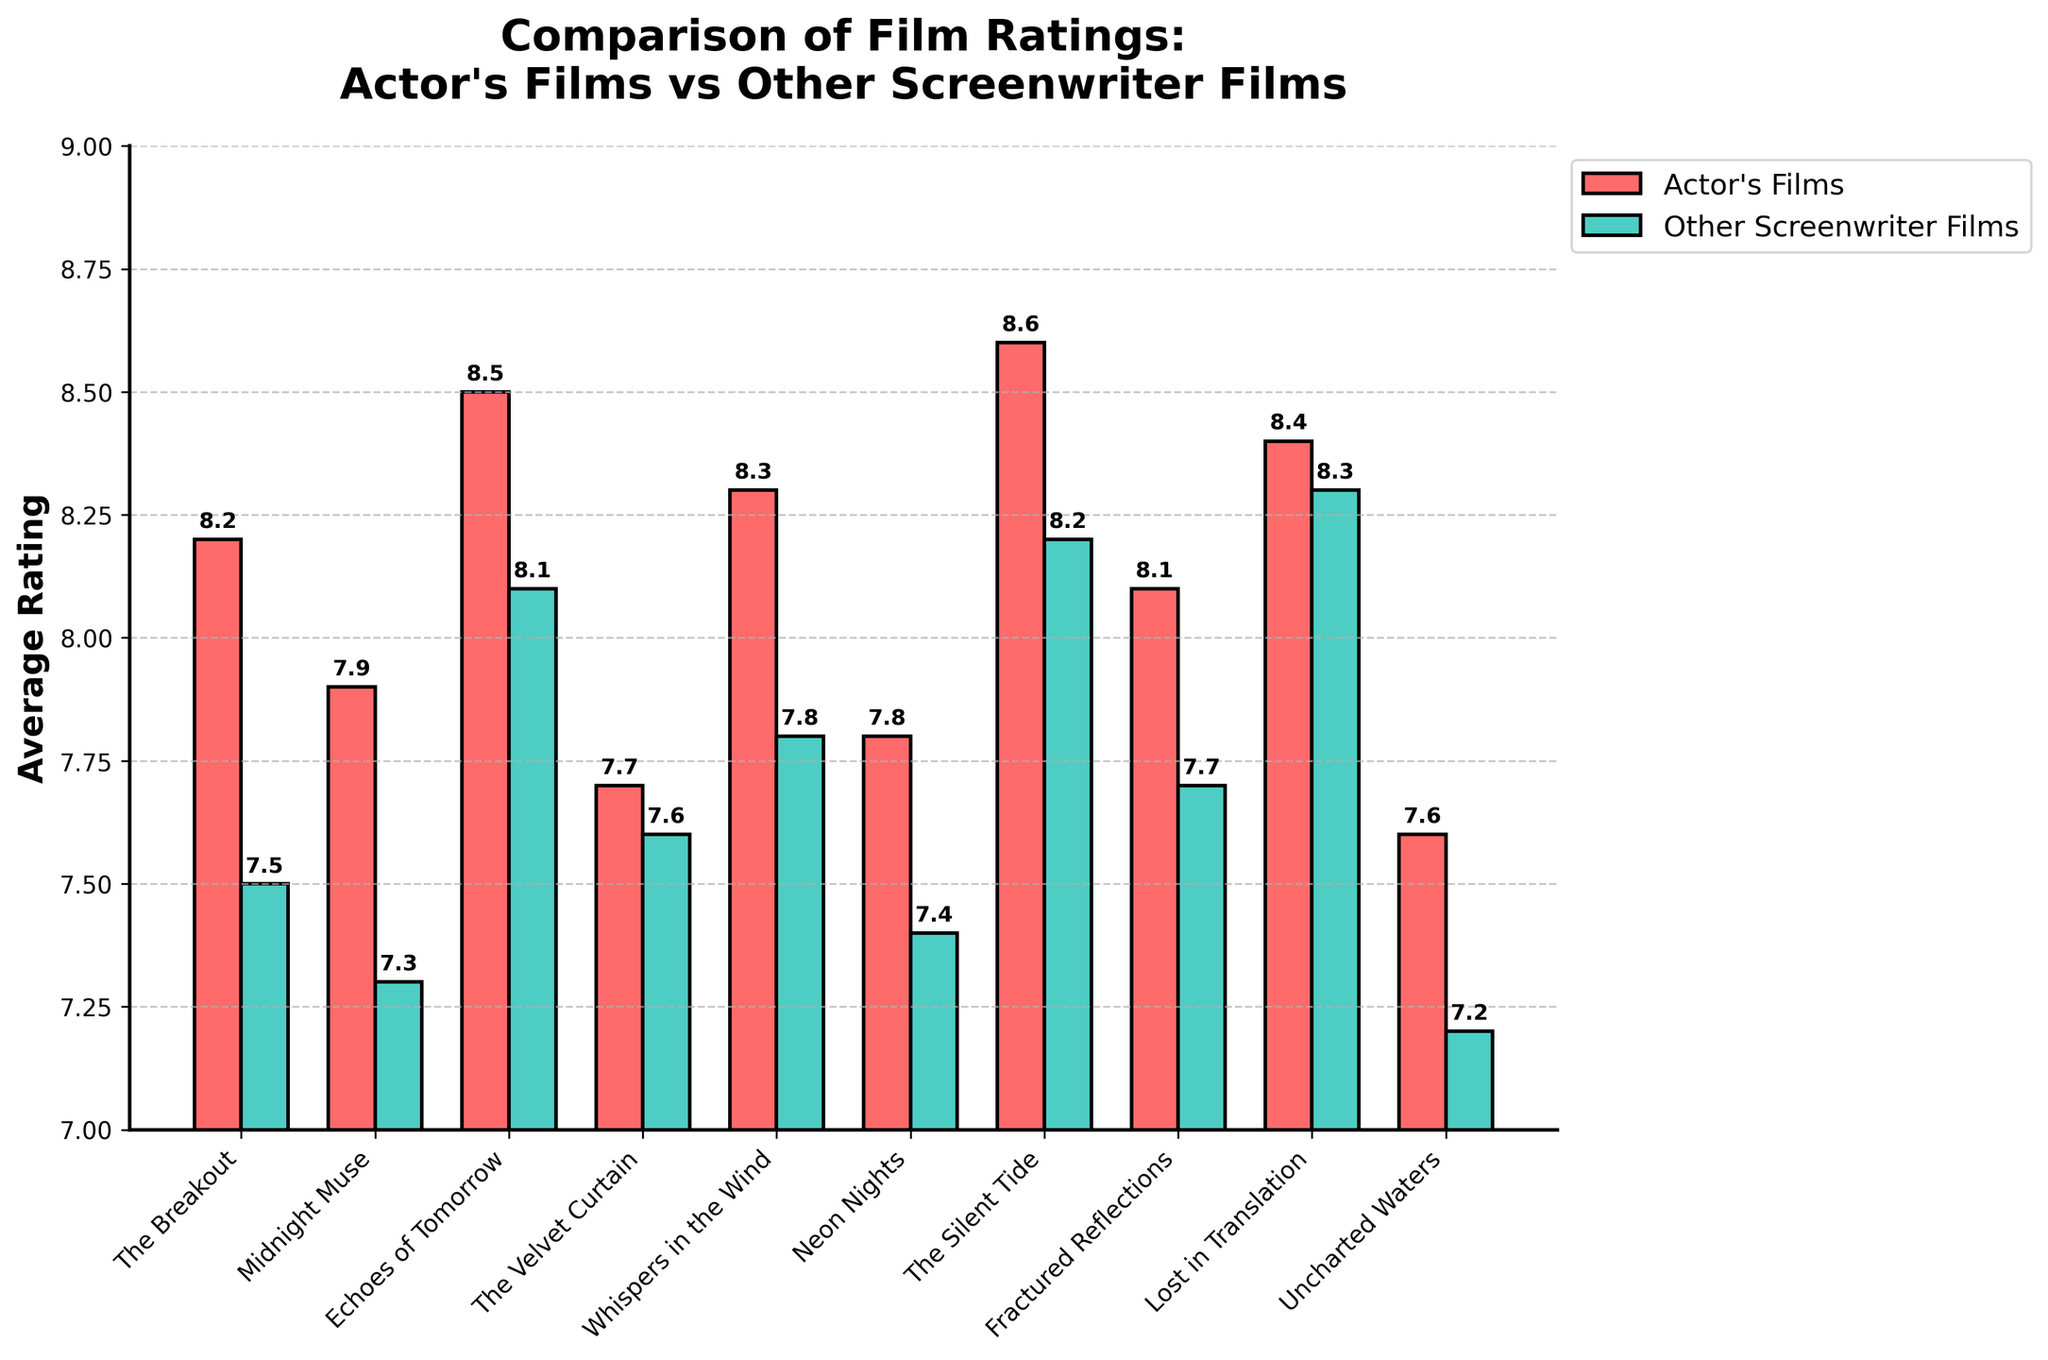Which film received the highest average rating among the actor's films? Look at the bars representing the actor's films and identify the tallest bar. "The Silent Tide" has the highest rating of 8.6 among the actor's films.
Answer: "The Silent Tide" Which film has the smallest difference in average ratings between the actor's films and other screenwriter films? Calculate the difference in average ratings for each film. "The Velvet Curtain" has the smallest difference of 0.1 (7.7 - 7.6).
Answer: "The Velvet Curtain" Which actor's film has the lowest average rating? Look for the shortest bar in the actor's films series. "Uncharted Waters" has the lowest average rating of 7.6.
Answer: "Uncharted Waters" Which film has the largest advantage in ratings for the actor's films over other screenwriter films? Calculate the rating difference for each film. "Whispers in the Wind" has the largest difference, where the actor's film is 8.3 and the other screenwriter film is 7.8, a difference of 0.5.
Answer: "Whispers in the Wind" What is the average rating of all the actor's films combined? Sum the average ratings of all the actor’s films and divide by the number of films. The sum is (8.2 + 7.9 + 8.5 + 7.7 + 8.3 + 7.8 + 8.6 + 8.1 + 8.4 + 7.6) = 81.1. Divide by 10 films: 81.1 / 10 = 8.11.
Answer: 8.11 What is the difference between the highest-rated and lowest-rated actor's film? Identify the highest (8.6) and lowest (7.6) ratings for the actor’s films and subtract the lowest from the highest: 8.6 - 7.6 = 1.0.
Answer: 1.0 What is the average rating of all other screenwriter films combined? Sum the average ratings of all the other screenwriter's films and divide by the number of films. The sum is (7.5 + 7.3 + 8.1 + 7.6 + 7.8 + 7.4 + 8.2 + 7.7 + 8.3 + 7.2) = 77.1. Divide by 10 films: 77.1 / 10 = 7.71.
Answer: 7.71 How many films have higher average ratings for the actor's films compared to the other screenwriter films? Count the film titles where the red bar is taller than the green bar. There are 8 films where the actor's films have higher average ratings.
Answer: 8 What color bars represent the actor's films? Identify the color of the bars corresponding to the actor's films. The bars representing the actor's films are red.
Answer: Red What is the average rating for 'The Breakout' in the actor's films? Look at the bar corresponding to 'The Breakout' in the actor’s films. The average rating for 'The Breakout' is 8.2.
Answer: 8.2 